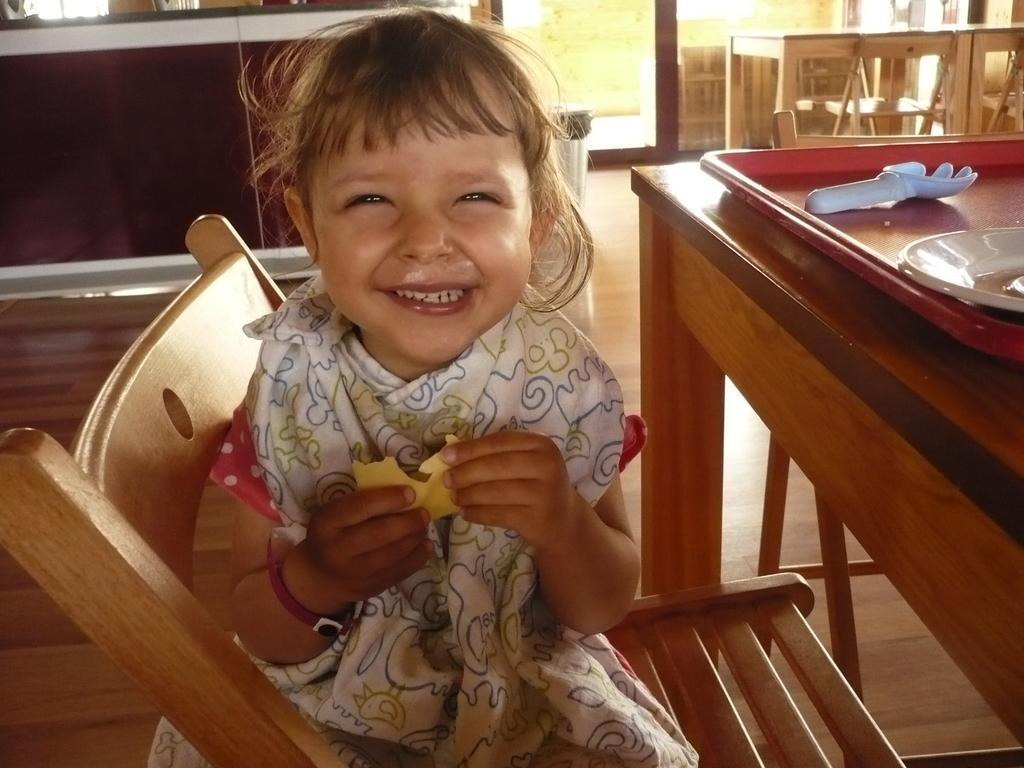Describe this image in one or two sentences. In this image I can see a girl sitting on a chair. On this table I can see a plate and a fork. In the background I can see few more chairs and tables. I can see a smile on her face. 